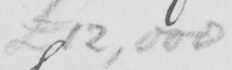Please transcribe the handwritten text in this image. £12,000 